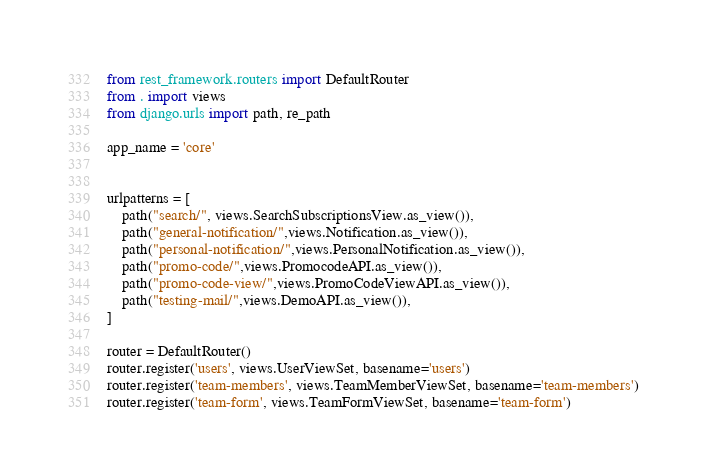Convert code to text. <code><loc_0><loc_0><loc_500><loc_500><_Python_>from rest_framework.routers import DefaultRouter
from . import views
from django.urls import path, re_path

app_name = 'core'


urlpatterns = [
	path("search/", views.SearchSubscriptionsView.as_view()),
	path("general-notification/",views.Notification.as_view()),
	path("personal-notification/",views.PersonalNotification.as_view()),
	path("promo-code/",views.PromocodeAPI.as_view()),
	path("promo-code-view/",views.PromoCodeViewAPI.as_view()),
	path("testing-mail/",views.DemoAPI.as_view()),
]

router = DefaultRouter()
router.register('users', views.UserViewSet, basename='users')
router.register('team-members', views.TeamMemberViewSet, basename='team-members')
router.register('team-form', views.TeamFormViewSet, basename='team-form')</code> 